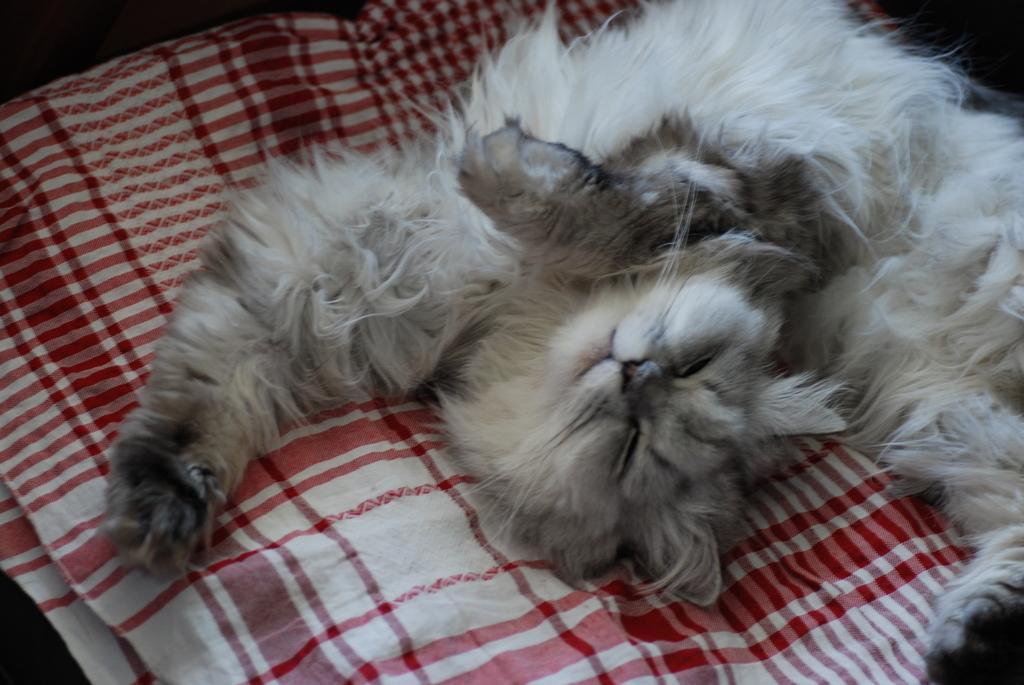Please provide a concise description of this image. In this picture, it seems like a cat is sleeping on a blanket in the foreground. 